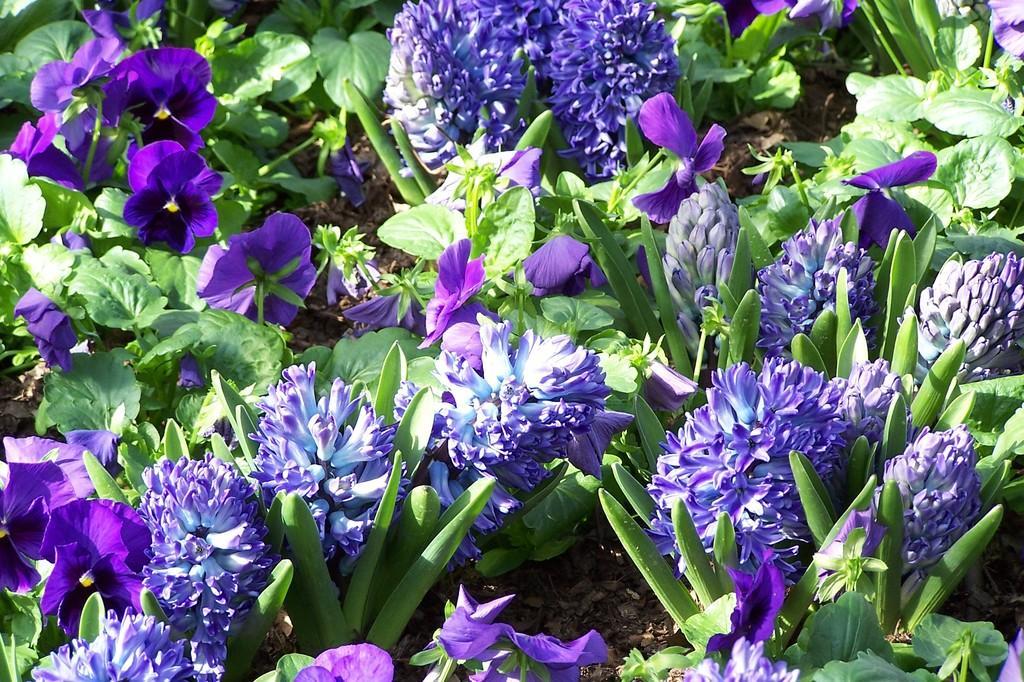How would you summarize this image in a sentence or two? In this image I can see flowering plants on the ground. This image is taken may be in a garden during a day. 